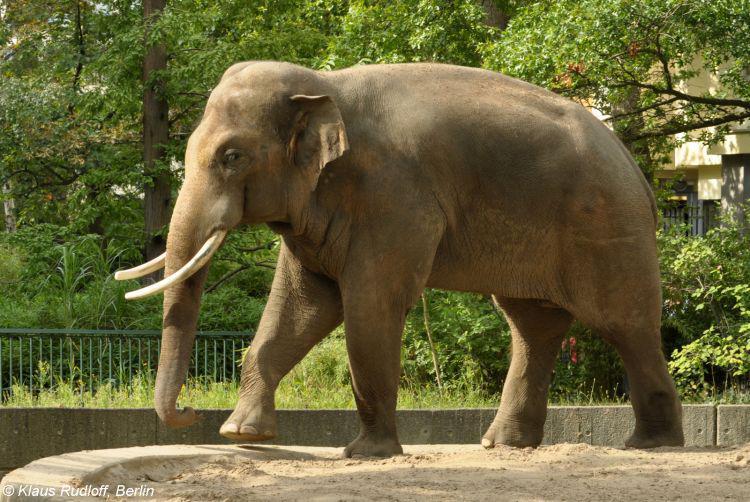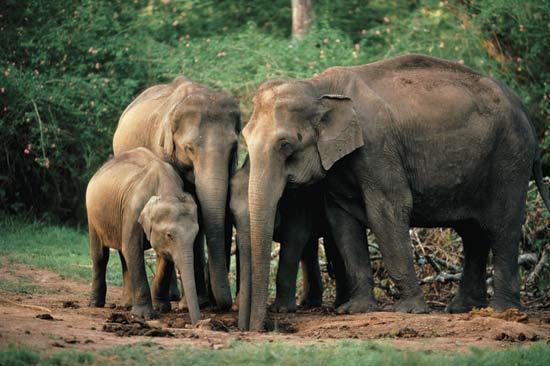The first image is the image on the left, the second image is the image on the right. Assess this claim about the two images: "There are no more than three elephants". Correct or not? Answer yes or no. No. 